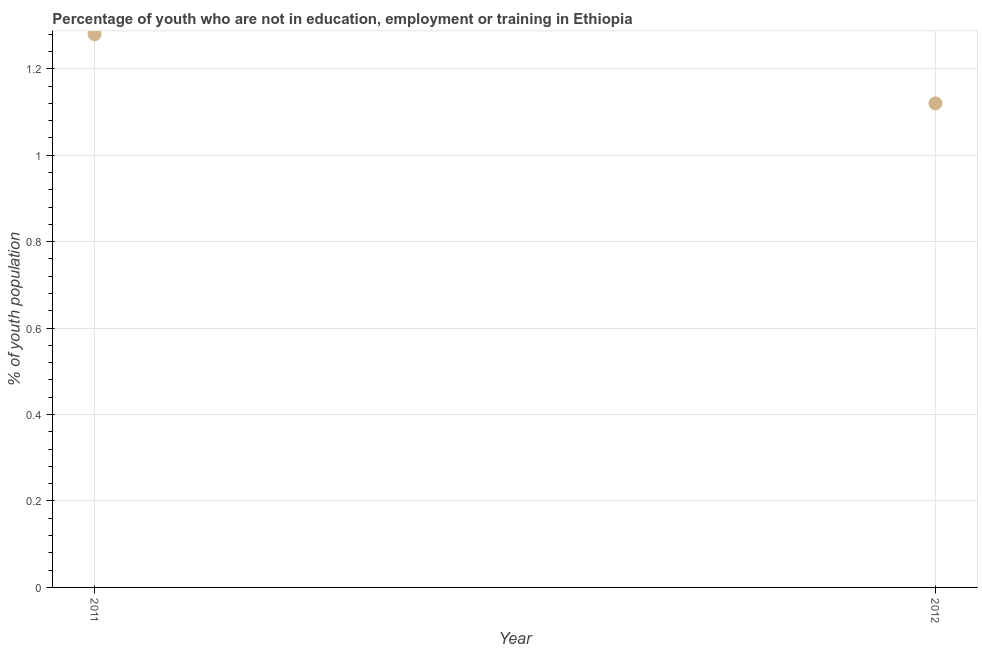What is the unemployed youth population in 2011?
Give a very brief answer. 1.28. Across all years, what is the maximum unemployed youth population?
Keep it short and to the point. 1.28. Across all years, what is the minimum unemployed youth population?
Keep it short and to the point. 1.12. In which year was the unemployed youth population maximum?
Offer a terse response. 2011. What is the sum of the unemployed youth population?
Your answer should be very brief. 2.4. What is the difference between the unemployed youth population in 2011 and 2012?
Provide a short and direct response. 0.16. What is the average unemployed youth population per year?
Give a very brief answer. 1.2. What is the median unemployed youth population?
Make the answer very short. 1.2. Do a majority of the years between 2012 and 2011 (inclusive) have unemployed youth population greater than 0.7600000000000001 %?
Provide a succinct answer. No. What is the ratio of the unemployed youth population in 2011 to that in 2012?
Ensure brevity in your answer.  1.14. How many dotlines are there?
Offer a terse response. 1. What is the difference between two consecutive major ticks on the Y-axis?
Ensure brevity in your answer.  0.2. Are the values on the major ticks of Y-axis written in scientific E-notation?
Give a very brief answer. No. What is the title of the graph?
Your response must be concise. Percentage of youth who are not in education, employment or training in Ethiopia. What is the label or title of the Y-axis?
Make the answer very short. % of youth population. What is the % of youth population in 2011?
Your answer should be compact. 1.28. What is the % of youth population in 2012?
Your answer should be compact. 1.12. What is the difference between the % of youth population in 2011 and 2012?
Ensure brevity in your answer.  0.16. What is the ratio of the % of youth population in 2011 to that in 2012?
Provide a short and direct response. 1.14. 